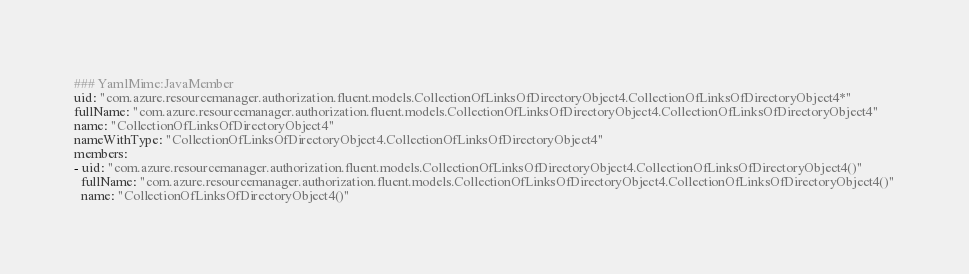<code> <loc_0><loc_0><loc_500><loc_500><_YAML_>### YamlMime:JavaMember
uid: "com.azure.resourcemanager.authorization.fluent.models.CollectionOfLinksOfDirectoryObject4.CollectionOfLinksOfDirectoryObject4*"
fullName: "com.azure.resourcemanager.authorization.fluent.models.CollectionOfLinksOfDirectoryObject4.CollectionOfLinksOfDirectoryObject4"
name: "CollectionOfLinksOfDirectoryObject4"
nameWithType: "CollectionOfLinksOfDirectoryObject4.CollectionOfLinksOfDirectoryObject4"
members:
- uid: "com.azure.resourcemanager.authorization.fluent.models.CollectionOfLinksOfDirectoryObject4.CollectionOfLinksOfDirectoryObject4()"
  fullName: "com.azure.resourcemanager.authorization.fluent.models.CollectionOfLinksOfDirectoryObject4.CollectionOfLinksOfDirectoryObject4()"
  name: "CollectionOfLinksOfDirectoryObject4()"</code> 